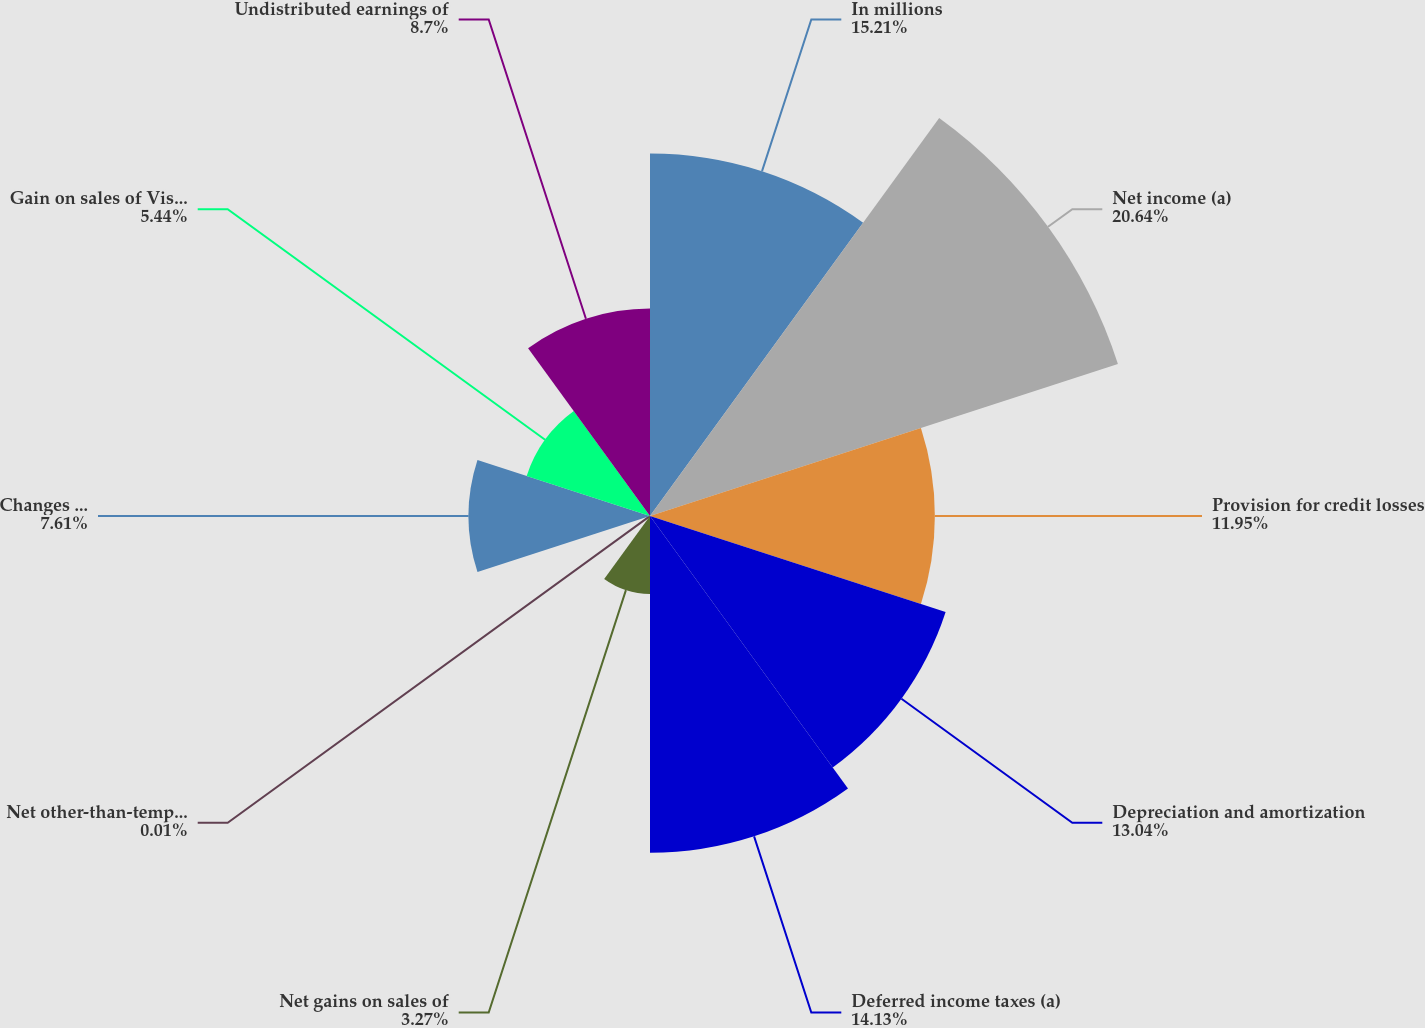Convert chart. <chart><loc_0><loc_0><loc_500><loc_500><pie_chart><fcel>In millions<fcel>Net income (a)<fcel>Provision for credit losses<fcel>Depreciation and amortization<fcel>Deferred income taxes (a)<fcel>Net gains on sales of<fcel>Net other-than-temporary<fcel>Changes in fair value of<fcel>Gain on sales of Visa Class B<fcel>Undistributed earnings of<nl><fcel>15.21%<fcel>20.64%<fcel>11.95%<fcel>13.04%<fcel>14.13%<fcel>3.27%<fcel>0.01%<fcel>7.61%<fcel>5.44%<fcel>8.7%<nl></chart> 